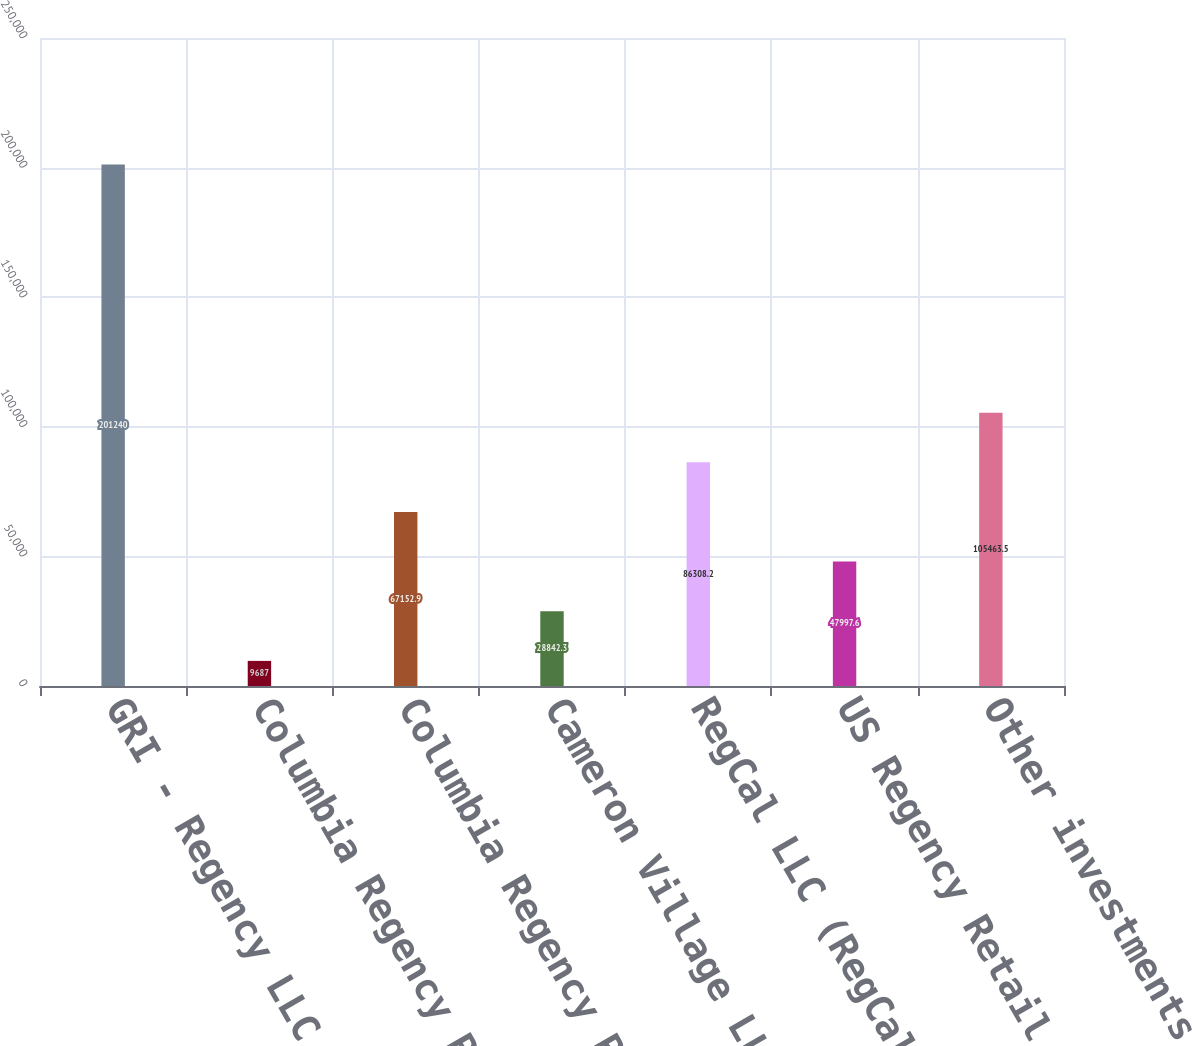<chart> <loc_0><loc_0><loc_500><loc_500><bar_chart><fcel>GRI - Regency LLC (GRIR)<fcel>Columbia Regency Retail<fcel>Columbia Regency Partners II<fcel>Cameron Village LLC (Cameron)<fcel>RegCal LLC (RegCal)<fcel>US Regency Retail I LLC (USAA)<fcel>Other investments in real<nl><fcel>201240<fcel>9687<fcel>67152.9<fcel>28842.3<fcel>86308.2<fcel>47997.6<fcel>105464<nl></chart> 